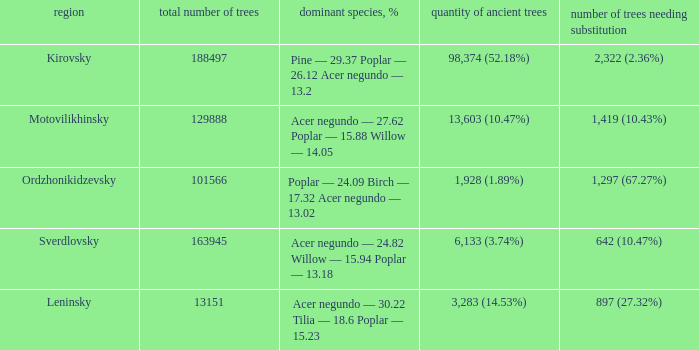What is the district when prevailing types, % is acer negundo — 30.22 tilia — 18.6 poplar — 15.23? Leninsky. 